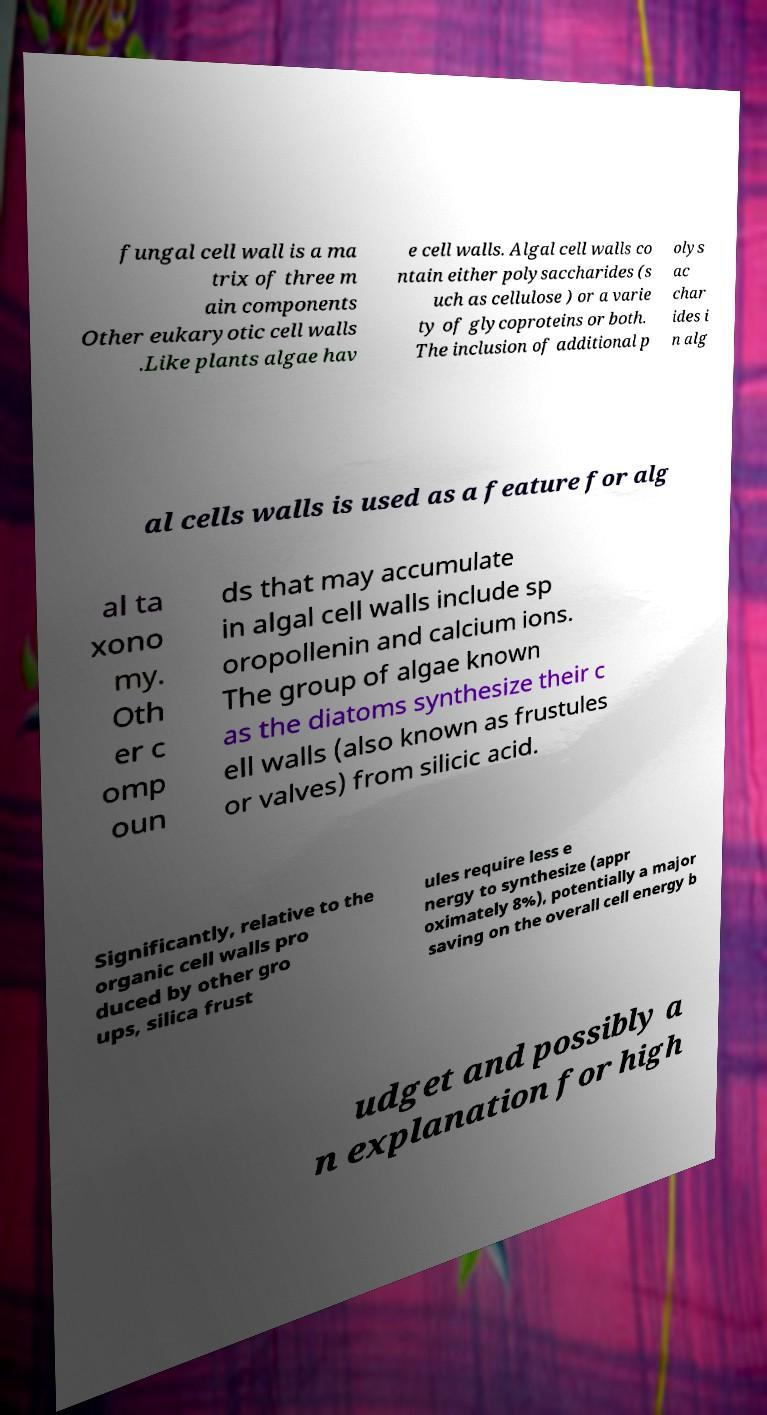Could you assist in decoding the text presented in this image and type it out clearly? fungal cell wall is a ma trix of three m ain components Other eukaryotic cell walls .Like plants algae hav e cell walls. Algal cell walls co ntain either polysaccharides (s uch as cellulose ) or a varie ty of glycoproteins or both. The inclusion of additional p olys ac char ides i n alg al cells walls is used as a feature for alg al ta xono my. Oth er c omp oun ds that may accumulate in algal cell walls include sp oropollenin and calcium ions. The group of algae known as the diatoms synthesize their c ell walls (also known as frustules or valves) from silicic acid. Significantly, relative to the organic cell walls pro duced by other gro ups, silica frust ules require less e nergy to synthesize (appr oximately 8%), potentially a major saving on the overall cell energy b udget and possibly a n explanation for high 